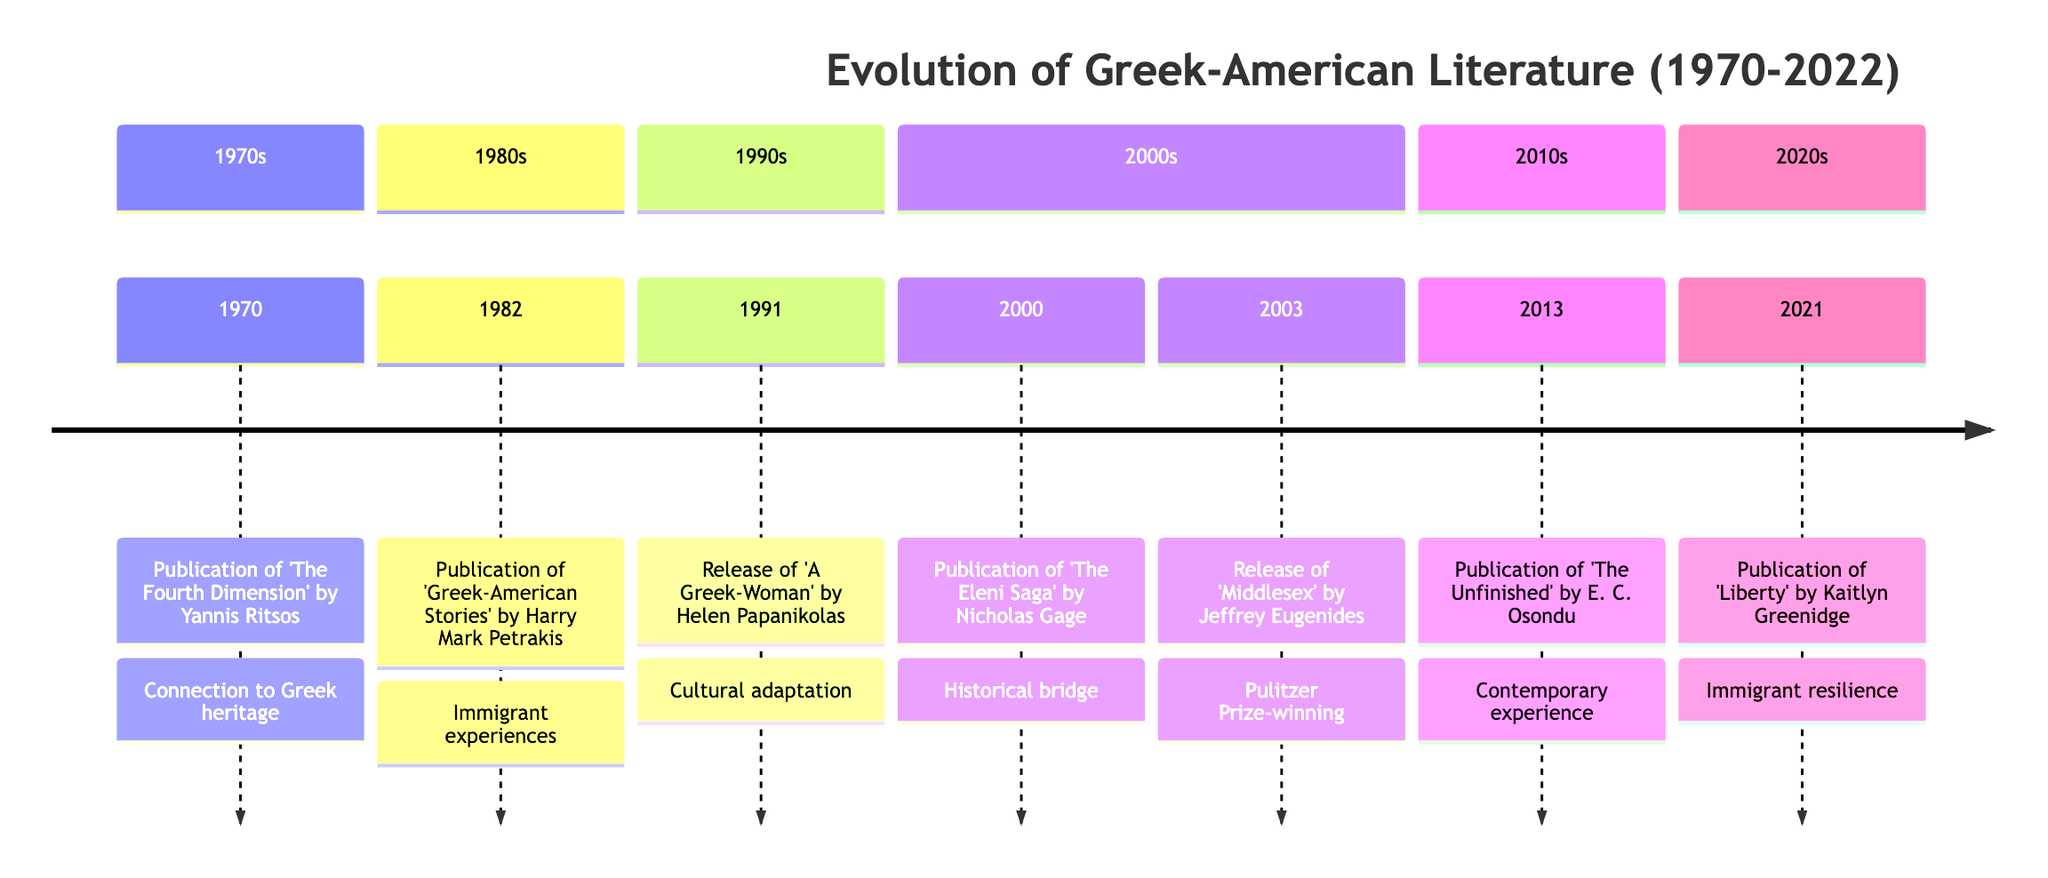What event occurred in 1982? In the timeline, under the 1980s section, there is a node that states "Publication of 'Greek-American Stories' by Harry Mark Petrakis.” This indicates the event that took place in that year.
Answer: Publication of 'Greek-American Stories' by Harry Mark Petrakis How many events are listed in the timeline? Counting the events from each section of the timeline, we have a total of seven events stated.
Answer: 7 Which publication focuses on the life of a Greek immigrant woman? Referring to the 1991 event, "Release of 'A Greek-Woman' by Helen Papanikolas," this is where the focus is on a Greek woman immigrant's life in America.
Answer: 'A Greek-Woman' by Helen Papanikolas What major theme is shared between 'The Eleni Saga' and 'Middlesex'? Analyzing the themes presented, both "The Eleni Saga" and "Middlesex" deal with the concept of identity and the immigrant experience, but specifically, they both encompass cultural heritage and personal journeys.
Answer: Identity and immigrant experience Which author’s work won a Pulitzer Prize? Looking at the entry from 2003, it mentions "Release of 'Middlesex' by Jeffrey Eugenides," who is noted to have won the Pulitzer Prize for this work.
Answer: Jeffrey Eugenides What year marks the release of a modern work exploring the contemporary Greek-American experience? The entry from 2013 states “Publication of 'The Unfinished' by E. C. Osondu,” indicating that this is the year of a more modern work focused on Greek-American life.
Answer: 2013 In which decade was 'The Fourth Dimension' published? Checking the timeline, 'The Fourth Dimension' by Yannis Ritsos was published in 1970, which is clearly marked in the 1970s section of the timeline.
Answer: 1970s 